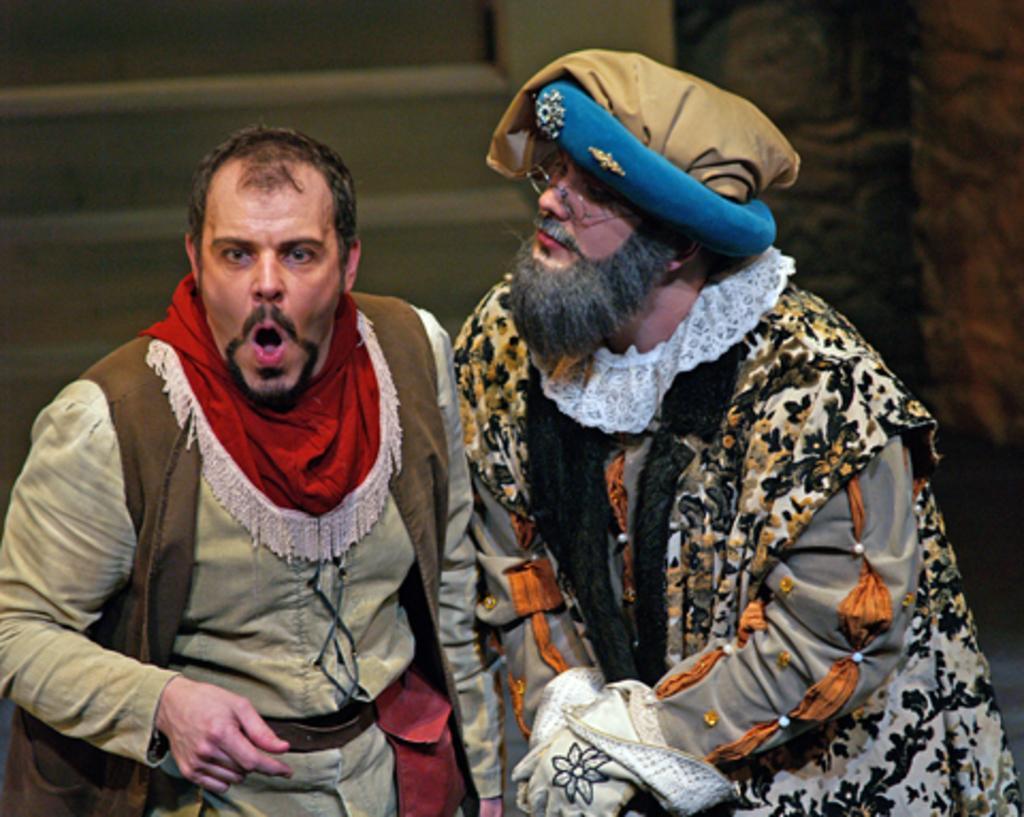Please provide a concise description of this image. In this image there are two men standing. The man to the left, his mouth is wide opened. Behind them there are steps. To the right there is a wall. 